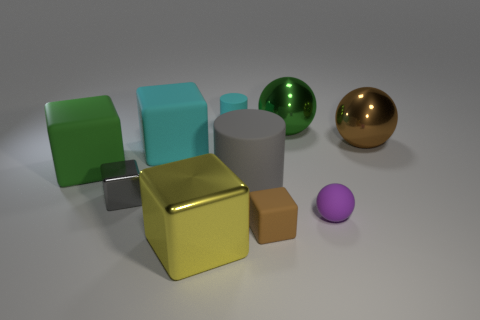Subtract all small cubes. How many cubes are left? 3 Subtract all yellow blocks. How many blocks are left? 4 Subtract 1 cubes. How many cubes are left? 4 Subtract all cylinders. How many objects are left? 8 Subtract all brown blocks. Subtract all brown spheres. How many blocks are left? 4 Subtract 1 gray cylinders. How many objects are left? 9 Subtract all small shiny things. Subtract all large gray things. How many objects are left? 8 Add 3 tiny brown rubber objects. How many tiny brown rubber objects are left? 4 Add 10 tiny green shiny objects. How many tiny green shiny objects exist? 10 